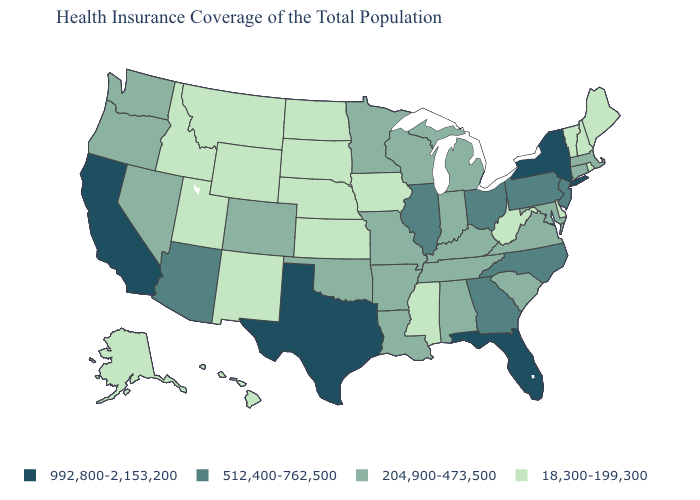Name the states that have a value in the range 512,400-762,500?
Answer briefly. Arizona, Georgia, Illinois, New Jersey, North Carolina, Ohio, Pennsylvania. Name the states that have a value in the range 18,300-199,300?
Keep it brief. Alaska, Delaware, Hawaii, Idaho, Iowa, Kansas, Maine, Mississippi, Montana, Nebraska, New Hampshire, New Mexico, North Dakota, Rhode Island, South Dakota, Utah, Vermont, West Virginia, Wyoming. Does North Dakota have the same value as Mississippi?
Short answer required. Yes. Among the states that border Colorado , which have the lowest value?
Short answer required. Kansas, Nebraska, New Mexico, Utah, Wyoming. What is the value of New Mexico?
Give a very brief answer. 18,300-199,300. Among the states that border Oregon , which have the highest value?
Short answer required. California. Does Utah have the lowest value in the USA?
Write a very short answer. Yes. Does Arkansas have a higher value than Montana?
Be succinct. Yes. Name the states that have a value in the range 18,300-199,300?
Keep it brief. Alaska, Delaware, Hawaii, Idaho, Iowa, Kansas, Maine, Mississippi, Montana, Nebraska, New Hampshire, New Mexico, North Dakota, Rhode Island, South Dakota, Utah, Vermont, West Virginia, Wyoming. Does the map have missing data?
Concise answer only. No. What is the value of North Dakota?
Concise answer only. 18,300-199,300. What is the value of Texas?
Quick response, please. 992,800-2,153,200. Does Wisconsin have the highest value in the USA?
Write a very short answer. No. 